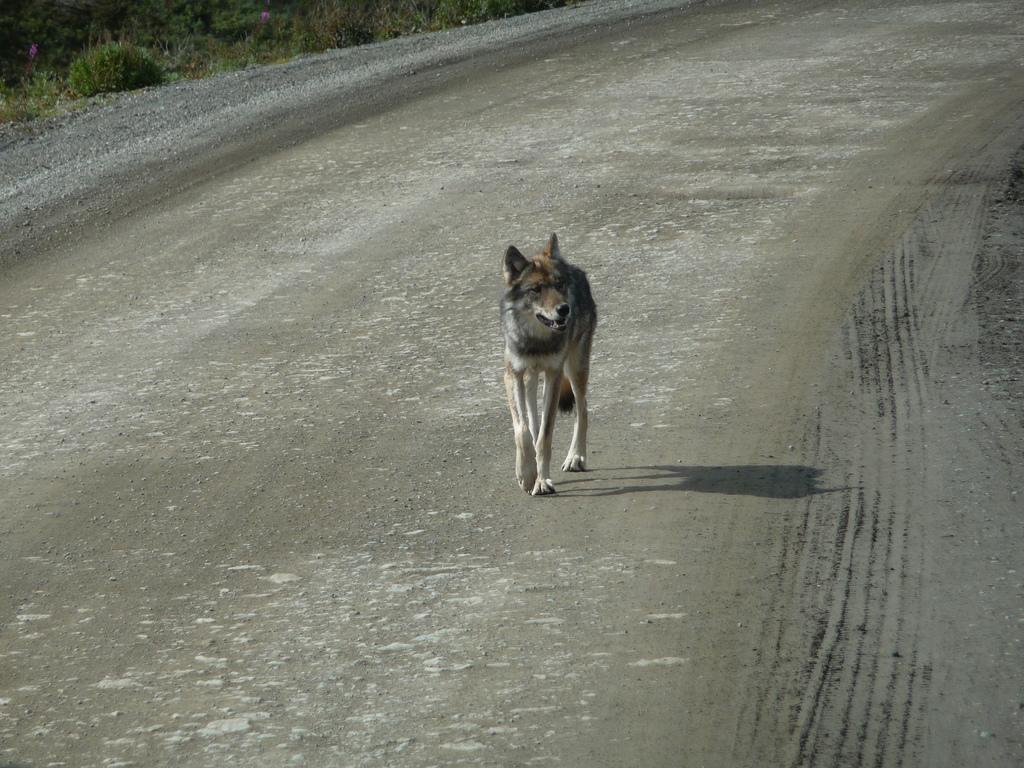What animal can be seen in the image? There is a dog in the image. Where is the dog located? The dog is on the road. What type of vegetation is visible in the image? There is grass visible in the image. What type of fiction is the dog reading at the party in the image? There is no fiction or party present in the image; it features a dog on the road with grass visible in the background. 